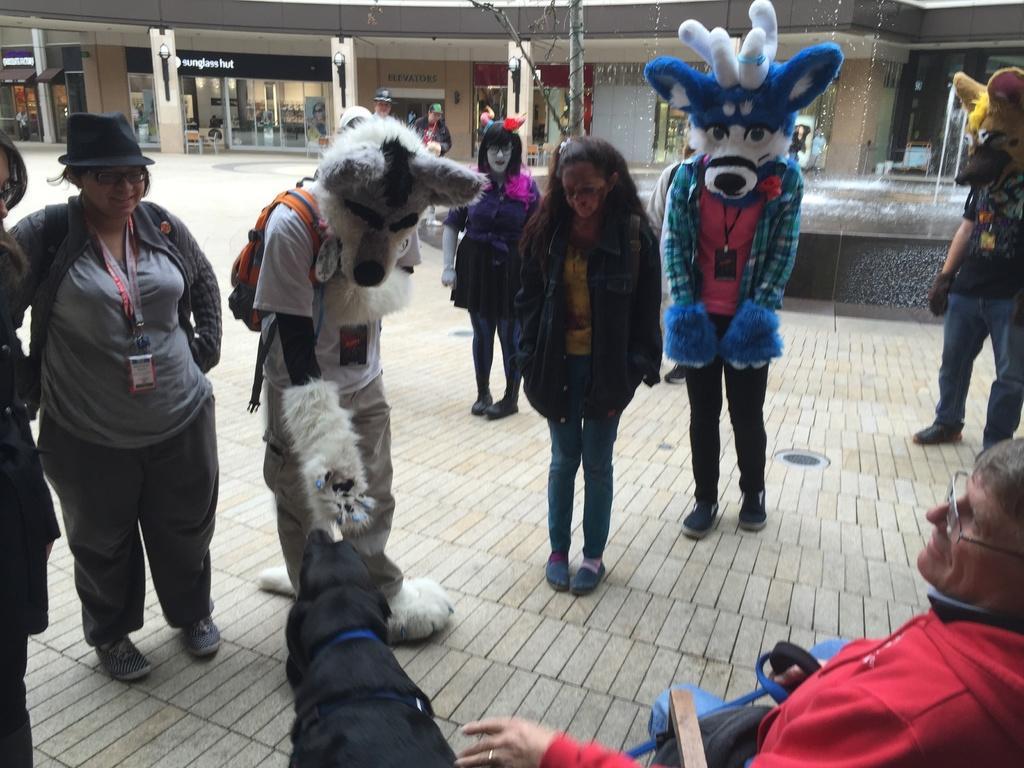Can you describe this image briefly? In this picture we can see some people are standing, some of them are wearing costumes, on the right side there is a water fountain, in the background we can see some stones and pillars. 